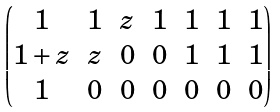<formula> <loc_0><loc_0><loc_500><loc_500>\begin{pmatrix} 1 & 1 & z & 1 & 1 & 1 & 1 \\ 1 + z & z & 0 & 0 & 1 & 1 & 1 \\ 1 & 0 & 0 & 0 & 0 & 0 & 0 \end{pmatrix}</formula> 